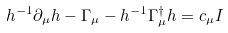Convert formula to latex. <formula><loc_0><loc_0><loc_500><loc_500>h ^ { - 1 } \partial _ { \mu } h - \Gamma _ { \mu } - h ^ { - 1 } \Gamma ^ { \dagger } _ { \mu } h = c _ { \mu } I</formula> 